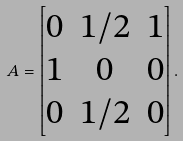Convert formula to latex. <formula><loc_0><loc_0><loc_500><loc_500>A = \begin{bmatrix} 0 & 1 / 2 & 1 \\ 1 & 0 & 0 \\ 0 & 1 / 2 & 0 \end{bmatrix} .</formula> 